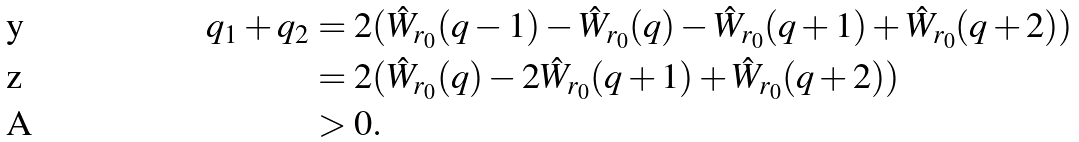Convert formula to latex. <formula><loc_0><loc_0><loc_500><loc_500>q _ { 1 } + q _ { 2 } & = 2 ( \hat { W } _ { r _ { 0 } } ( q - 1 ) - \hat { W } _ { r _ { 0 } } ( q ) - \hat { W } _ { r _ { 0 } } ( q + 1 ) + \hat { W } _ { r _ { 0 } } ( q + 2 ) ) \\ & = 2 ( \hat { W } _ { r _ { 0 } } ( q ) - 2 \hat { W } _ { r _ { 0 } } ( q + 1 ) + \hat { W } _ { r _ { 0 } } ( q + 2 ) ) \\ & > 0 .</formula> 